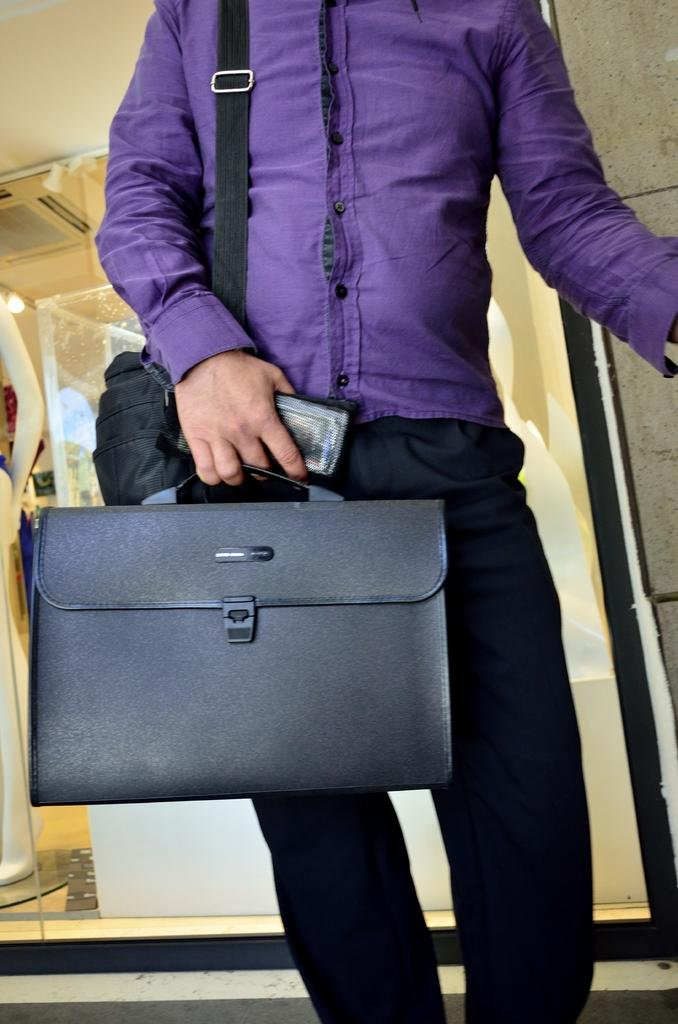What color is the shirt the man is wearing in the image? The man is wearing a purple shirt in the image. What is the man carrying in addition to his mobile phone? The man is holding a bag and a suitcase in the image. What object is the man holding in his hand? The man is holding a mobile phone in the image. Can you describe the lighting in the image? There is a light visible in the image. What other object can be seen in the image besides the man and his belongings? There is a mannequin in the image. What type of snail can be seen crawling on the man's shirt in the image? There is no snail present on the man's shirt in the image. What is the man using to keep his hands warm in the image? The man is not wearing mittens or any other hand-warming accessories in the image. 